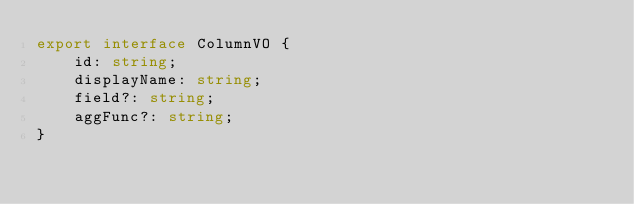<code> <loc_0><loc_0><loc_500><loc_500><_TypeScript_>export interface ColumnVO {
    id: string;
    displayName: string;
    field?: string;
    aggFunc?: string;
}
</code> 